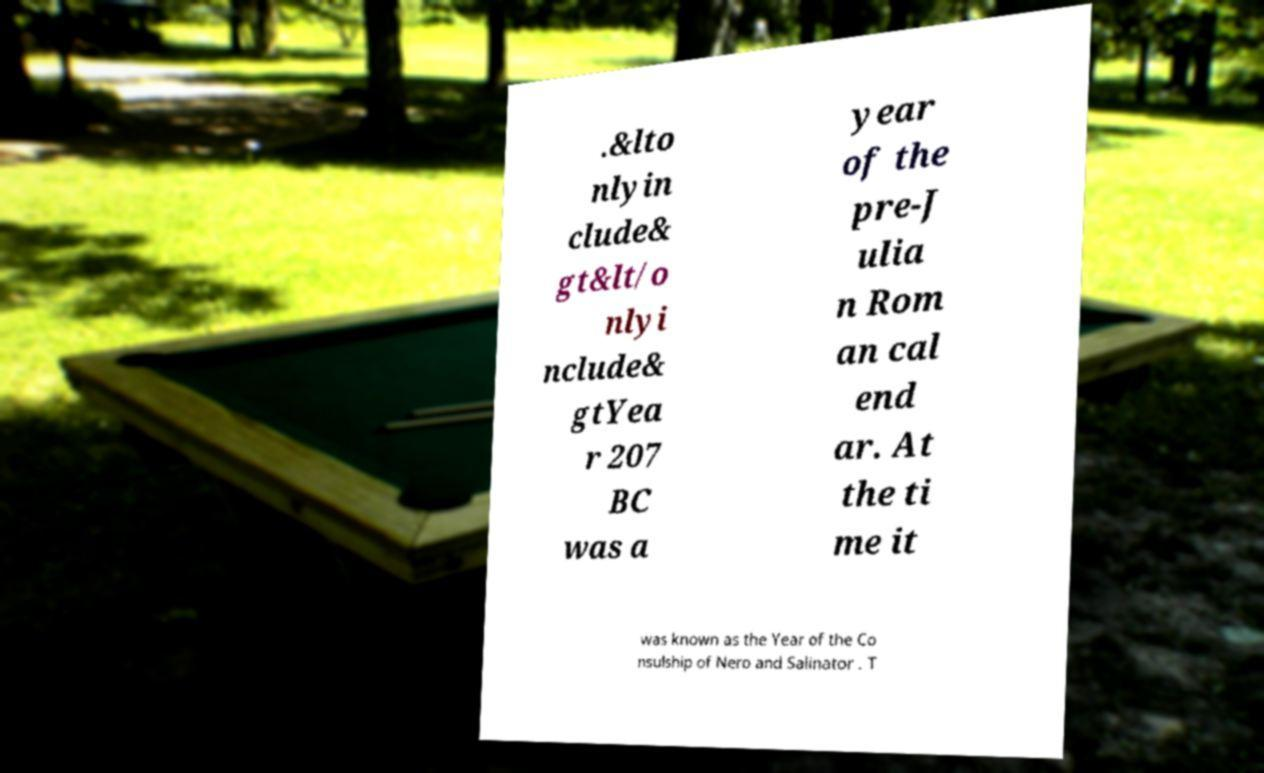For documentation purposes, I need the text within this image transcribed. Could you provide that? .&lto nlyin clude& gt&lt/o nlyi nclude& gtYea r 207 BC was a year of the pre-J ulia n Rom an cal end ar. At the ti me it was known as the Year of the Co nsulship of Nero and Salinator . T 